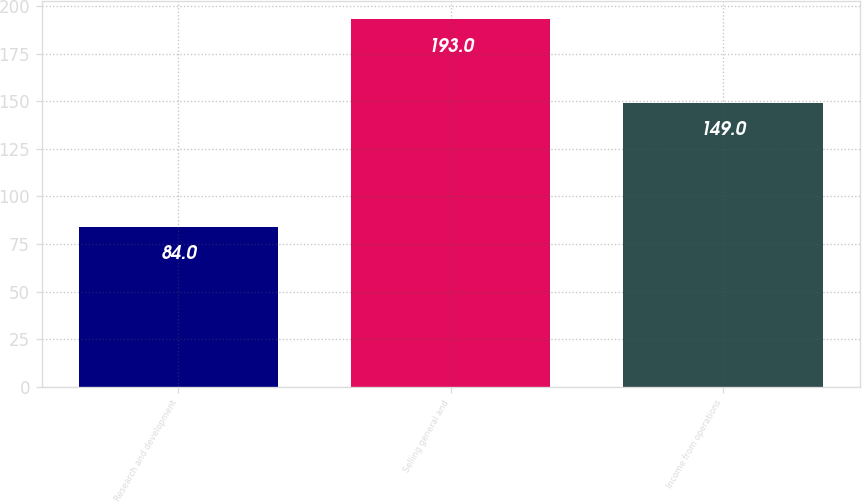Convert chart. <chart><loc_0><loc_0><loc_500><loc_500><bar_chart><fcel>Research and development<fcel>Selling general and<fcel>Income from operations<nl><fcel>84<fcel>193<fcel>149<nl></chart> 